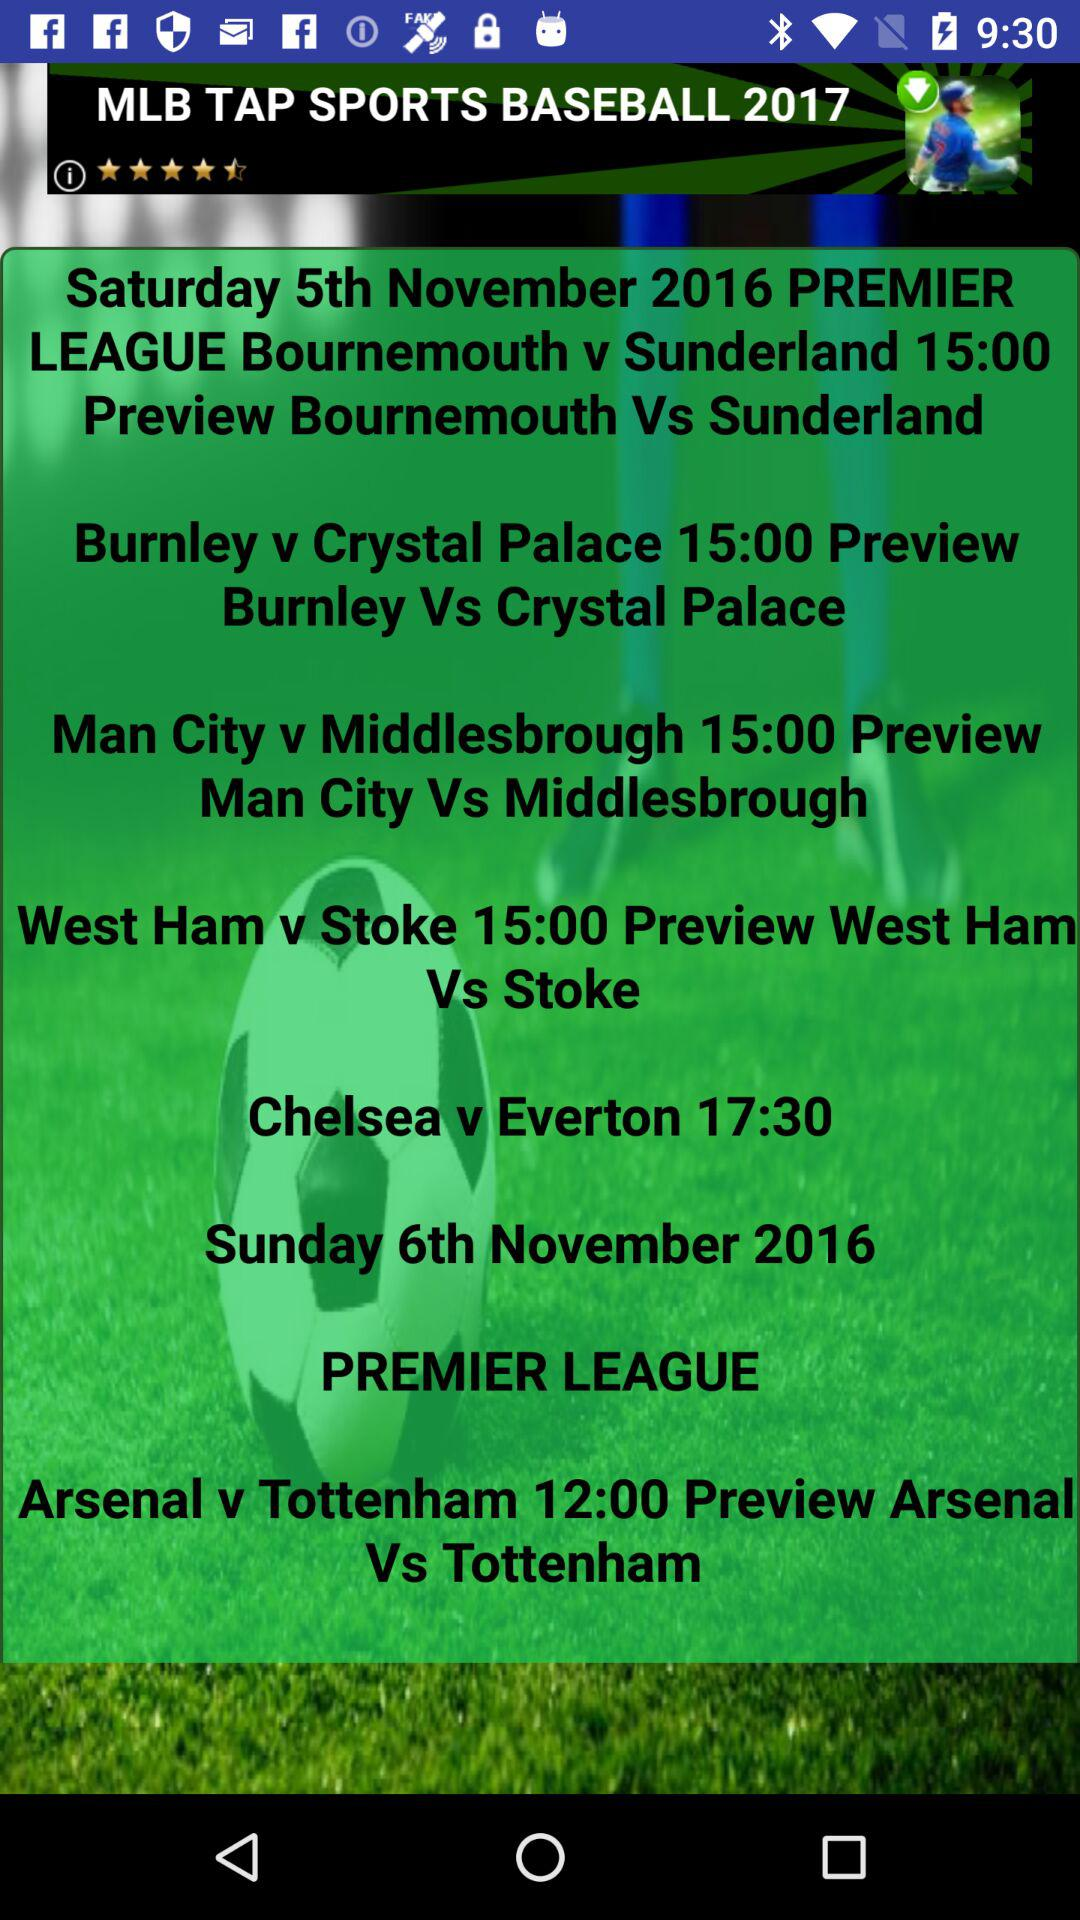What is the date of Arsenal v Tottenham in the Premier League? The date is Sunday, November 6, 2016. 